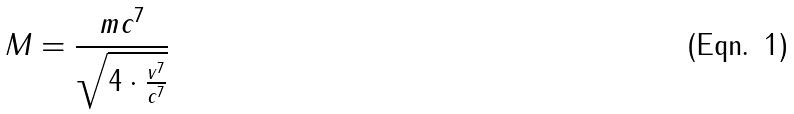Convert formula to latex. <formula><loc_0><loc_0><loc_500><loc_500>M = \frac { m c ^ { 7 } } { \sqrt { 4 \cdot \frac { v ^ { 7 } } { c ^ { 7 } } } }</formula> 